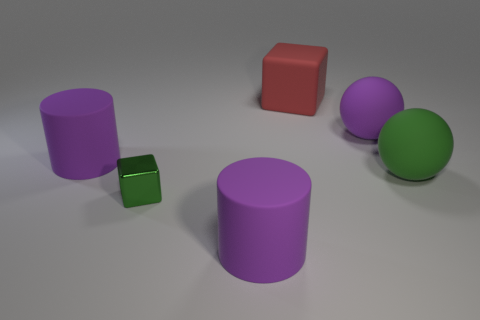Add 1 purple metallic things. How many objects exist? 7 Subtract all green balls. How many balls are left? 1 Subtract 2 cylinders. How many cylinders are left? 0 Subtract all balls. How many objects are left? 4 Subtract all purple cylinders. How many cyan spheres are left? 0 Add 1 tiny green objects. How many tiny green objects are left? 2 Add 5 green matte things. How many green matte things exist? 6 Subtract 0 brown cubes. How many objects are left? 6 Subtract all cyan cubes. Subtract all gray cylinders. How many cubes are left? 2 Subtract all small brown matte cubes. Subtract all purple spheres. How many objects are left? 5 